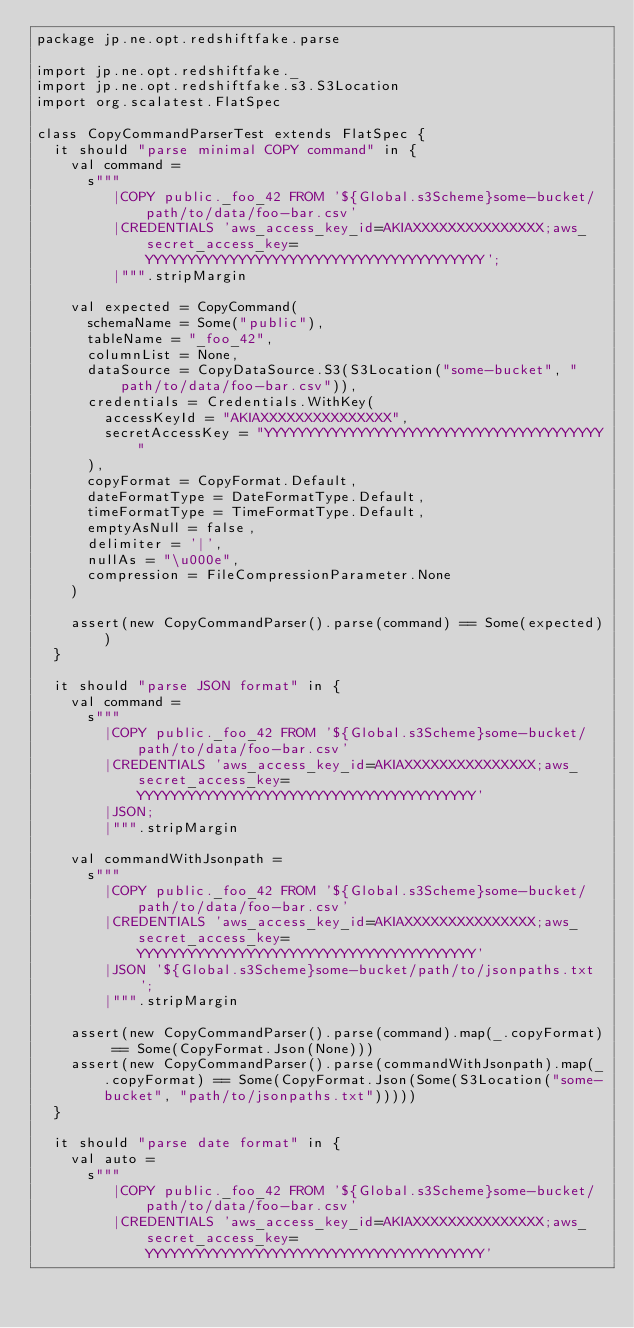<code> <loc_0><loc_0><loc_500><loc_500><_Scala_>package jp.ne.opt.redshiftfake.parse

import jp.ne.opt.redshiftfake._
import jp.ne.opt.redshiftfake.s3.S3Location
import org.scalatest.FlatSpec

class CopyCommandParserTest extends FlatSpec {
  it should "parse minimal COPY command" in {
    val command =
      s"""
         |COPY public._foo_42 FROM '${Global.s3Scheme}some-bucket/path/to/data/foo-bar.csv'
         |CREDENTIALS 'aws_access_key_id=AKIAXXXXXXXXXXXXXXX;aws_secret_access_key=YYYYYYYYYYYYYYYYYYYYYYYYYYYYYYYYYYYYYYYY';
         |""".stripMargin

    val expected = CopyCommand(
      schemaName = Some("public"),
      tableName = "_foo_42",
      columnList = None,
      dataSource = CopyDataSource.S3(S3Location("some-bucket", "path/to/data/foo-bar.csv")),
      credentials = Credentials.WithKey(
        accessKeyId = "AKIAXXXXXXXXXXXXXXX",
        secretAccessKey = "YYYYYYYYYYYYYYYYYYYYYYYYYYYYYYYYYYYYYYYY"
      ),
      copyFormat = CopyFormat.Default,
      dateFormatType = DateFormatType.Default,
      timeFormatType = TimeFormatType.Default,
      emptyAsNull = false,
      delimiter = '|',
      nullAs = "\u000e",
      compression = FileCompressionParameter.None
    )

    assert(new CopyCommandParser().parse(command) == Some(expected))
  }

  it should "parse JSON format" in {
    val command =
      s"""
        |COPY public._foo_42 FROM '${Global.s3Scheme}some-bucket/path/to/data/foo-bar.csv'
        |CREDENTIALS 'aws_access_key_id=AKIAXXXXXXXXXXXXXXX;aws_secret_access_key=YYYYYYYYYYYYYYYYYYYYYYYYYYYYYYYYYYYYYYYY'
        |JSON;
        |""".stripMargin

    val commandWithJsonpath =
      s"""
        |COPY public._foo_42 FROM '${Global.s3Scheme}some-bucket/path/to/data/foo-bar.csv'
        |CREDENTIALS 'aws_access_key_id=AKIAXXXXXXXXXXXXXXX;aws_secret_access_key=YYYYYYYYYYYYYYYYYYYYYYYYYYYYYYYYYYYYYYYY'
        |JSON '${Global.s3Scheme}some-bucket/path/to/jsonpaths.txt';
        |""".stripMargin

    assert(new CopyCommandParser().parse(command).map(_.copyFormat) == Some(CopyFormat.Json(None)))
    assert(new CopyCommandParser().parse(commandWithJsonpath).map(_.copyFormat) == Some(CopyFormat.Json(Some(S3Location("some-bucket", "path/to/jsonpaths.txt")))))
  }

  it should "parse date format" in {
    val auto =
      s"""
         |COPY public._foo_42 FROM '${Global.s3Scheme}some-bucket/path/to/data/foo-bar.csv'
         |CREDENTIALS 'aws_access_key_id=AKIAXXXXXXXXXXXXXXX;aws_secret_access_key=YYYYYYYYYYYYYYYYYYYYYYYYYYYYYYYYYYYYYYYY'</code> 